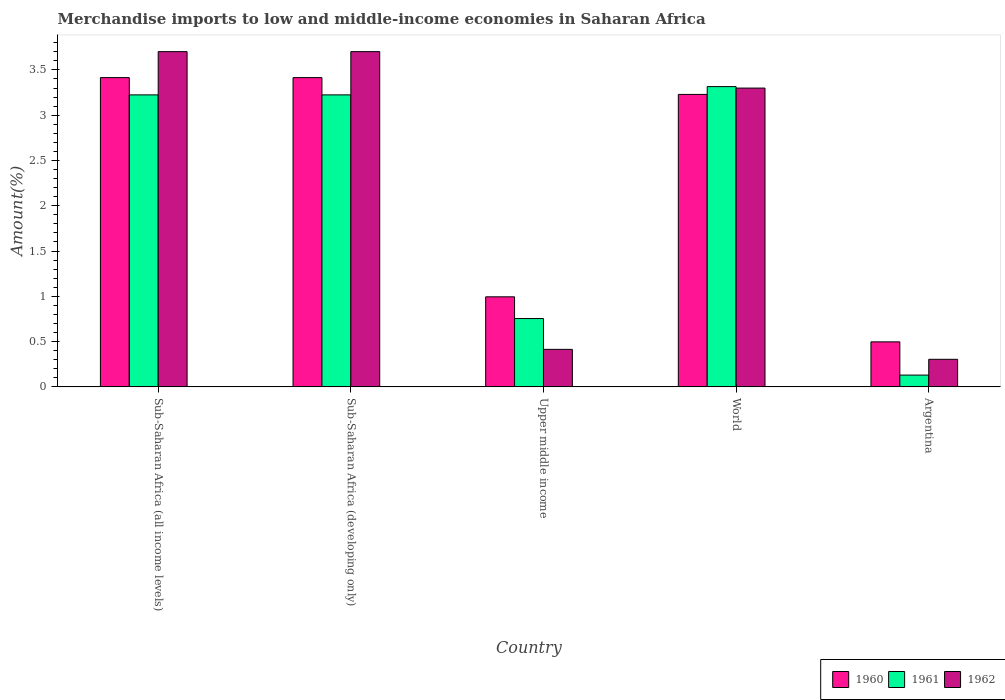How many bars are there on the 2nd tick from the right?
Your answer should be very brief. 3. What is the label of the 5th group of bars from the left?
Provide a succinct answer. Argentina. In how many cases, is the number of bars for a given country not equal to the number of legend labels?
Keep it short and to the point. 0. What is the percentage of amount earned from merchandise imports in 1960 in Upper middle income?
Make the answer very short. 0.99. Across all countries, what is the maximum percentage of amount earned from merchandise imports in 1961?
Offer a very short reply. 3.32. Across all countries, what is the minimum percentage of amount earned from merchandise imports in 1961?
Offer a terse response. 0.13. In which country was the percentage of amount earned from merchandise imports in 1962 maximum?
Provide a succinct answer. Sub-Saharan Africa (all income levels). In which country was the percentage of amount earned from merchandise imports in 1962 minimum?
Your answer should be compact. Argentina. What is the total percentage of amount earned from merchandise imports in 1961 in the graph?
Ensure brevity in your answer.  10.65. What is the difference between the percentage of amount earned from merchandise imports in 1960 in Sub-Saharan Africa (all income levels) and that in Upper middle income?
Offer a very short reply. 2.42. What is the difference between the percentage of amount earned from merchandise imports in 1960 in Argentina and the percentage of amount earned from merchandise imports in 1962 in Upper middle income?
Keep it short and to the point. 0.08. What is the average percentage of amount earned from merchandise imports in 1962 per country?
Make the answer very short. 2.28. What is the difference between the percentage of amount earned from merchandise imports of/in 1961 and percentage of amount earned from merchandise imports of/in 1962 in Upper middle income?
Your answer should be compact. 0.34. In how many countries, is the percentage of amount earned from merchandise imports in 1962 greater than 2.6 %?
Provide a succinct answer. 3. What is the ratio of the percentage of amount earned from merchandise imports in 1961 in Sub-Saharan Africa (all income levels) to that in World?
Ensure brevity in your answer.  0.97. What is the difference between the highest and the second highest percentage of amount earned from merchandise imports in 1960?
Offer a very short reply. -0.19. What is the difference between the highest and the lowest percentage of amount earned from merchandise imports in 1961?
Keep it short and to the point. 3.19. In how many countries, is the percentage of amount earned from merchandise imports in 1960 greater than the average percentage of amount earned from merchandise imports in 1960 taken over all countries?
Your response must be concise. 3. What does the 3rd bar from the left in Upper middle income represents?
Your response must be concise. 1962. What does the 1st bar from the right in Argentina represents?
Your answer should be compact. 1962. How many bars are there?
Offer a very short reply. 15. What is the difference between two consecutive major ticks on the Y-axis?
Your answer should be very brief. 0.5. Are the values on the major ticks of Y-axis written in scientific E-notation?
Ensure brevity in your answer.  No. Does the graph contain any zero values?
Make the answer very short. No. What is the title of the graph?
Provide a short and direct response. Merchandise imports to low and middle-income economies in Saharan Africa. Does "1962" appear as one of the legend labels in the graph?
Offer a very short reply. Yes. What is the label or title of the X-axis?
Ensure brevity in your answer.  Country. What is the label or title of the Y-axis?
Provide a succinct answer. Amount(%). What is the Amount(%) of 1960 in Sub-Saharan Africa (all income levels)?
Ensure brevity in your answer.  3.42. What is the Amount(%) in 1961 in Sub-Saharan Africa (all income levels)?
Your response must be concise. 3.22. What is the Amount(%) in 1962 in Sub-Saharan Africa (all income levels)?
Ensure brevity in your answer.  3.7. What is the Amount(%) in 1960 in Sub-Saharan Africa (developing only)?
Ensure brevity in your answer.  3.42. What is the Amount(%) of 1961 in Sub-Saharan Africa (developing only)?
Offer a terse response. 3.22. What is the Amount(%) in 1962 in Sub-Saharan Africa (developing only)?
Make the answer very short. 3.7. What is the Amount(%) in 1960 in Upper middle income?
Provide a succinct answer. 0.99. What is the Amount(%) of 1961 in Upper middle income?
Offer a terse response. 0.75. What is the Amount(%) of 1962 in Upper middle income?
Your answer should be compact. 0.41. What is the Amount(%) of 1960 in World?
Make the answer very short. 3.23. What is the Amount(%) in 1961 in World?
Give a very brief answer. 3.32. What is the Amount(%) of 1962 in World?
Keep it short and to the point. 3.3. What is the Amount(%) of 1960 in Argentina?
Your answer should be very brief. 0.5. What is the Amount(%) in 1961 in Argentina?
Make the answer very short. 0.13. What is the Amount(%) of 1962 in Argentina?
Make the answer very short. 0.3. Across all countries, what is the maximum Amount(%) in 1960?
Make the answer very short. 3.42. Across all countries, what is the maximum Amount(%) in 1961?
Provide a short and direct response. 3.32. Across all countries, what is the maximum Amount(%) of 1962?
Provide a short and direct response. 3.7. Across all countries, what is the minimum Amount(%) in 1960?
Offer a terse response. 0.5. Across all countries, what is the minimum Amount(%) of 1961?
Your answer should be compact. 0.13. Across all countries, what is the minimum Amount(%) in 1962?
Provide a short and direct response. 0.3. What is the total Amount(%) in 1960 in the graph?
Your answer should be compact. 11.55. What is the total Amount(%) of 1961 in the graph?
Provide a short and direct response. 10.65. What is the total Amount(%) of 1962 in the graph?
Provide a succinct answer. 11.42. What is the difference between the Amount(%) in 1961 in Sub-Saharan Africa (all income levels) and that in Sub-Saharan Africa (developing only)?
Your response must be concise. 0. What is the difference between the Amount(%) of 1962 in Sub-Saharan Africa (all income levels) and that in Sub-Saharan Africa (developing only)?
Offer a terse response. 0. What is the difference between the Amount(%) in 1960 in Sub-Saharan Africa (all income levels) and that in Upper middle income?
Keep it short and to the point. 2.42. What is the difference between the Amount(%) in 1961 in Sub-Saharan Africa (all income levels) and that in Upper middle income?
Your response must be concise. 2.47. What is the difference between the Amount(%) in 1962 in Sub-Saharan Africa (all income levels) and that in Upper middle income?
Provide a short and direct response. 3.29. What is the difference between the Amount(%) of 1960 in Sub-Saharan Africa (all income levels) and that in World?
Your answer should be compact. 0.19. What is the difference between the Amount(%) in 1961 in Sub-Saharan Africa (all income levels) and that in World?
Your answer should be compact. -0.09. What is the difference between the Amount(%) of 1962 in Sub-Saharan Africa (all income levels) and that in World?
Offer a terse response. 0.4. What is the difference between the Amount(%) of 1960 in Sub-Saharan Africa (all income levels) and that in Argentina?
Provide a succinct answer. 2.92. What is the difference between the Amount(%) of 1961 in Sub-Saharan Africa (all income levels) and that in Argentina?
Keep it short and to the point. 3.09. What is the difference between the Amount(%) in 1962 in Sub-Saharan Africa (all income levels) and that in Argentina?
Your answer should be very brief. 3.4. What is the difference between the Amount(%) in 1960 in Sub-Saharan Africa (developing only) and that in Upper middle income?
Offer a very short reply. 2.42. What is the difference between the Amount(%) of 1961 in Sub-Saharan Africa (developing only) and that in Upper middle income?
Provide a short and direct response. 2.47. What is the difference between the Amount(%) in 1962 in Sub-Saharan Africa (developing only) and that in Upper middle income?
Offer a terse response. 3.29. What is the difference between the Amount(%) of 1960 in Sub-Saharan Africa (developing only) and that in World?
Your answer should be very brief. 0.19. What is the difference between the Amount(%) of 1961 in Sub-Saharan Africa (developing only) and that in World?
Your response must be concise. -0.09. What is the difference between the Amount(%) in 1962 in Sub-Saharan Africa (developing only) and that in World?
Make the answer very short. 0.4. What is the difference between the Amount(%) in 1960 in Sub-Saharan Africa (developing only) and that in Argentina?
Offer a very short reply. 2.92. What is the difference between the Amount(%) in 1961 in Sub-Saharan Africa (developing only) and that in Argentina?
Your response must be concise. 3.09. What is the difference between the Amount(%) of 1962 in Sub-Saharan Africa (developing only) and that in Argentina?
Keep it short and to the point. 3.4. What is the difference between the Amount(%) in 1960 in Upper middle income and that in World?
Make the answer very short. -2.24. What is the difference between the Amount(%) of 1961 in Upper middle income and that in World?
Your answer should be compact. -2.56. What is the difference between the Amount(%) of 1962 in Upper middle income and that in World?
Provide a short and direct response. -2.89. What is the difference between the Amount(%) in 1960 in Upper middle income and that in Argentina?
Make the answer very short. 0.5. What is the difference between the Amount(%) in 1961 in Upper middle income and that in Argentina?
Make the answer very short. 0.62. What is the difference between the Amount(%) in 1962 in Upper middle income and that in Argentina?
Your response must be concise. 0.11. What is the difference between the Amount(%) of 1960 in World and that in Argentina?
Make the answer very short. 2.73. What is the difference between the Amount(%) in 1961 in World and that in Argentina?
Make the answer very short. 3.19. What is the difference between the Amount(%) of 1962 in World and that in Argentina?
Offer a very short reply. 3. What is the difference between the Amount(%) of 1960 in Sub-Saharan Africa (all income levels) and the Amount(%) of 1961 in Sub-Saharan Africa (developing only)?
Keep it short and to the point. 0.19. What is the difference between the Amount(%) of 1960 in Sub-Saharan Africa (all income levels) and the Amount(%) of 1962 in Sub-Saharan Africa (developing only)?
Provide a succinct answer. -0.29. What is the difference between the Amount(%) in 1961 in Sub-Saharan Africa (all income levels) and the Amount(%) in 1962 in Sub-Saharan Africa (developing only)?
Make the answer very short. -0.48. What is the difference between the Amount(%) in 1960 in Sub-Saharan Africa (all income levels) and the Amount(%) in 1961 in Upper middle income?
Give a very brief answer. 2.66. What is the difference between the Amount(%) in 1960 in Sub-Saharan Africa (all income levels) and the Amount(%) in 1962 in Upper middle income?
Keep it short and to the point. 3. What is the difference between the Amount(%) of 1961 in Sub-Saharan Africa (all income levels) and the Amount(%) of 1962 in Upper middle income?
Keep it short and to the point. 2.81. What is the difference between the Amount(%) in 1960 in Sub-Saharan Africa (all income levels) and the Amount(%) in 1961 in World?
Offer a terse response. 0.1. What is the difference between the Amount(%) of 1960 in Sub-Saharan Africa (all income levels) and the Amount(%) of 1962 in World?
Give a very brief answer. 0.12. What is the difference between the Amount(%) of 1961 in Sub-Saharan Africa (all income levels) and the Amount(%) of 1962 in World?
Keep it short and to the point. -0.08. What is the difference between the Amount(%) of 1960 in Sub-Saharan Africa (all income levels) and the Amount(%) of 1961 in Argentina?
Provide a succinct answer. 3.29. What is the difference between the Amount(%) in 1960 in Sub-Saharan Africa (all income levels) and the Amount(%) in 1962 in Argentina?
Provide a short and direct response. 3.11. What is the difference between the Amount(%) in 1961 in Sub-Saharan Africa (all income levels) and the Amount(%) in 1962 in Argentina?
Your response must be concise. 2.92. What is the difference between the Amount(%) of 1960 in Sub-Saharan Africa (developing only) and the Amount(%) of 1961 in Upper middle income?
Your answer should be compact. 2.66. What is the difference between the Amount(%) of 1960 in Sub-Saharan Africa (developing only) and the Amount(%) of 1962 in Upper middle income?
Your answer should be very brief. 3. What is the difference between the Amount(%) of 1961 in Sub-Saharan Africa (developing only) and the Amount(%) of 1962 in Upper middle income?
Provide a short and direct response. 2.81. What is the difference between the Amount(%) of 1960 in Sub-Saharan Africa (developing only) and the Amount(%) of 1961 in World?
Provide a succinct answer. 0.1. What is the difference between the Amount(%) of 1960 in Sub-Saharan Africa (developing only) and the Amount(%) of 1962 in World?
Provide a short and direct response. 0.12. What is the difference between the Amount(%) in 1961 in Sub-Saharan Africa (developing only) and the Amount(%) in 1962 in World?
Offer a terse response. -0.08. What is the difference between the Amount(%) of 1960 in Sub-Saharan Africa (developing only) and the Amount(%) of 1961 in Argentina?
Give a very brief answer. 3.29. What is the difference between the Amount(%) of 1960 in Sub-Saharan Africa (developing only) and the Amount(%) of 1962 in Argentina?
Offer a very short reply. 3.11. What is the difference between the Amount(%) of 1961 in Sub-Saharan Africa (developing only) and the Amount(%) of 1962 in Argentina?
Give a very brief answer. 2.92. What is the difference between the Amount(%) in 1960 in Upper middle income and the Amount(%) in 1961 in World?
Make the answer very short. -2.32. What is the difference between the Amount(%) in 1960 in Upper middle income and the Amount(%) in 1962 in World?
Your response must be concise. -2.31. What is the difference between the Amount(%) of 1961 in Upper middle income and the Amount(%) of 1962 in World?
Keep it short and to the point. -2.54. What is the difference between the Amount(%) in 1960 in Upper middle income and the Amount(%) in 1961 in Argentina?
Offer a very short reply. 0.86. What is the difference between the Amount(%) of 1960 in Upper middle income and the Amount(%) of 1962 in Argentina?
Keep it short and to the point. 0.69. What is the difference between the Amount(%) of 1961 in Upper middle income and the Amount(%) of 1962 in Argentina?
Make the answer very short. 0.45. What is the difference between the Amount(%) of 1960 in World and the Amount(%) of 1961 in Argentina?
Ensure brevity in your answer.  3.1. What is the difference between the Amount(%) in 1960 in World and the Amount(%) in 1962 in Argentina?
Provide a succinct answer. 2.93. What is the difference between the Amount(%) of 1961 in World and the Amount(%) of 1962 in Argentina?
Make the answer very short. 3.01. What is the average Amount(%) of 1960 per country?
Keep it short and to the point. 2.31. What is the average Amount(%) in 1961 per country?
Offer a terse response. 2.13. What is the average Amount(%) of 1962 per country?
Your answer should be compact. 2.28. What is the difference between the Amount(%) in 1960 and Amount(%) in 1961 in Sub-Saharan Africa (all income levels)?
Offer a terse response. 0.19. What is the difference between the Amount(%) in 1960 and Amount(%) in 1962 in Sub-Saharan Africa (all income levels)?
Offer a terse response. -0.29. What is the difference between the Amount(%) of 1961 and Amount(%) of 1962 in Sub-Saharan Africa (all income levels)?
Give a very brief answer. -0.48. What is the difference between the Amount(%) in 1960 and Amount(%) in 1961 in Sub-Saharan Africa (developing only)?
Offer a terse response. 0.19. What is the difference between the Amount(%) in 1960 and Amount(%) in 1962 in Sub-Saharan Africa (developing only)?
Offer a terse response. -0.29. What is the difference between the Amount(%) in 1961 and Amount(%) in 1962 in Sub-Saharan Africa (developing only)?
Provide a succinct answer. -0.48. What is the difference between the Amount(%) in 1960 and Amount(%) in 1961 in Upper middle income?
Provide a short and direct response. 0.24. What is the difference between the Amount(%) of 1960 and Amount(%) of 1962 in Upper middle income?
Ensure brevity in your answer.  0.58. What is the difference between the Amount(%) of 1961 and Amount(%) of 1962 in Upper middle income?
Provide a succinct answer. 0.34. What is the difference between the Amount(%) of 1960 and Amount(%) of 1961 in World?
Your answer should be compact. -0.09. What is the difference between the Amount(%) in 1960 and Amount(%) in 1962 in World?
Keep it short and to the point. -0.07. What is the difference between the Amount(%) of 1961 and Amount(%) of 1962 in World?
Provide a succinct answer. 0.02. What is the difference between the Amount(%) in 1960 and Amount(%) in 1961 in Argentina?
Give a very brief answer. 0.37. What is the difference between the Amount(%) in 1960 and Amount(%) in 1962 in Argentina?
Your answer should be very brief. 0.19. What is the difference between the Amount(%) of 1961 and Amount(%) of 1962 in Argentina?
Ensure brevity in your answer.  -0.17. What is the ratio of the Amount(%) of 1961 in Sub-Saharan Africa (all income levels) to that in Sub-Saharan Africa (developing only)?
Give a very brief answer. 1. What is the ratio of the Amount(%) in 1962 in Sub-Saharan Africa (all income levels) to that in Sub-Saharan Africa (developing only)?
Provide a succinct answer. 1. What is the ratio of the Amount(%) of 1960 in Sub-Saharan Africa (all income levels) to that in Upper middle income?
Offer a terse response. 3.43. What is the ratio of the Amount(%) in 1961 in Sub-Saharan Africa (all income levels) to that in Upper middle income?
Your response must be concise. 4.27. What is the ratio of the Amount(%) in 1962 in Sub-Saharan Africa (all income levels) to that in Upper middle income?
Provide a succinct answer. 8.94. What is the ratio of the Amount(%) in 1960 in Sub-Saharan Africa (all income levels) to that in World?
Offer a very short reply. 1.06. What is the ratio of the Amount(%) of 1961 in Sub-Saharan Africa (all income levels) to that in World?
Your answer should be very brief. 0.97. What is the ratio of the Amount(%) of 1962 in Sub-Saharan Africa (all income levels) to that in World?
Make the answer very short. 1.12. What is the ratio of the Amount(%) of 1960 in Sub-Saharan Africa (all income levels) to that in Argentina?
Make the answer very short. 6.87. What is the ratio of the Amount(%) in 1961 in Sub-Saharan Africa (all income levels) to that in Argentina?
Your answer should be compact. 24.78. What is the ratio of the Amount(%) in 1962 in Sub-Saharan Africa (all income levels) to that in Argentina?
Offer a very short reply. 12.16. What is the ratio of the Amount(%) of 1960 in Sub-Saharan Africa (developing only) to that in Upper middle income?
Keep it short and to the point. 3.43. What is the ratio of the Amount(%) of 1961 in Sub-Saharan Africa (developing only) to that in Upper middle income?
Provide a succinct answer. 4.27. What is the ratio of the Amount(%) in 1962 in Sub-Saharan Africa (developing only) to that in Upper middle income?
Ensure brevity in your answer.  8.94. What is the ratio of the Amount(%) in 1960 in Sub-Saharan Africa (developing only) to that in World?
Make the answer very short. 1.06. What is the ratio of the Amount(%) of 1961 in Sub-Saharan Africa (developing only) to that in World?
Make the answer very short. 0.97. What is the ratio of the Amount(%) in 1962 in Sub-Saharan Africa (developing only) to that in World?
Make the answer very short. 1.12. What is the ratio of the Amount(%) of 1960 in Sub-Saharan Africa (developing only) to that in Argentina?
Keep it short and to the point. 6.87. What is the ratio of the Amount(%) of 1961 in Sub-Saharan Africa (developing only) to that in Argentina?
Your answer should be compact. 24.78. What is the ratio of the Amount(%) in 1962 in Sub-Saharan Africa (developing only) to that in Argentina?
Make the answer very short. 12.16. What is the ratio of the Amount(%) of 1960 in Upper middle income to that in World?
Offer a terse response. 0.31. What is the ratio of the Amount(%) of 1961 in Upper middle income to that in World?
Ensure brevity in your answer.  0.23. What is the ratio of the Amount(%) in 1962 in Upper middle income to that in World?
Give a very brief answer. 0.13. What is the ratio of the Amount(%) in 1960 in Upper middle income to that in Argentina?
Your response must be concise. 2. What is the ratio of the Amount(%) in 1961 in Upper middle income to that in Argentina?
Provide a short and direct response. 5.8. What is the ratio of the Amount(%) in 1962 in Upper middle income to that in Argentina?
Keep it short and to the point. 1.36. What is the ratio of the Amount(%) in 1960 in World to that in Argentina?
Offer a very short reply. 6.5. What is the ratio of the Amount(%) in 1961 in World to that in Argentina?
Keep it short and to the point. 25.48. What is the ratio of the Amount(%) in 1962 in World to that in Argentina?
Your answer should be very brief. 10.84. What is the difference between the highest and the second highest Amount(%) of 1960?
Your answer should be very brief. 0. What is the difference between the highest and the second highest Amount(%) of 1961?
Offer a very short reply. 0.09. What is the difference between the highest and the second highest Amount(%) of 1962?
Your answer should be very brief. 0. What is the difference between the highest and the lowest Amount(%) of 1960?
Offer a terse response. 2.92. What is the difference between the highest and the lowest Amount(%) in 1961?
Provide a short and direct response. 3.19. What is the difference between the highest and the lowest Amount(%) in 1962?
Offer a terse response. 3.4. 